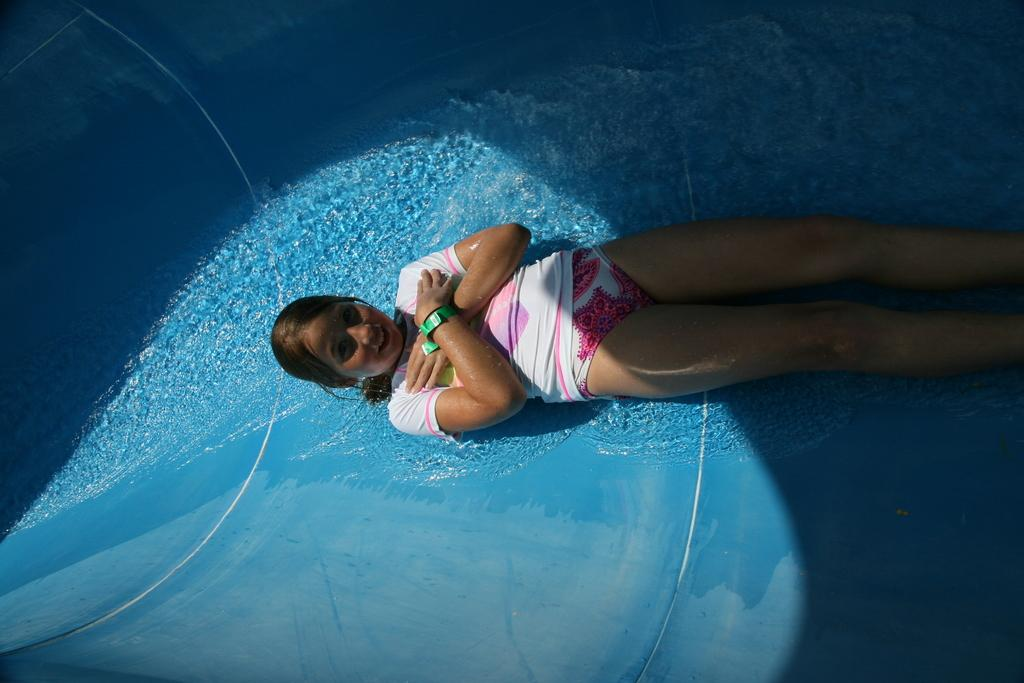What is the position of the girl in the image? The girl is lying in the image. What is happening with the water in the image? Water is flowing in the image. What color is the surface of the water? The surface of the water is blue. What type of ring is the girl wearing on her tongue in the image? There is no ring or tongue visible in the image; the girl is lying and water is flowing. 